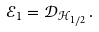<formula> <loc_0><loc_0><loc_500><loc_500>\mathcal { E } _ { 1 } = \mathcal { D } _ { \mathcal { H } _ { 1 / 2 } } \, .</formula> 